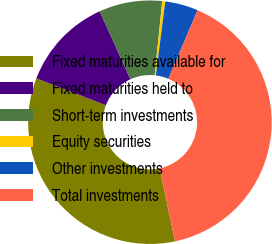Convert chart to OTSL. <chart><loc_0><loc_0><loc_500><loc_500><pie_chart><fcel>Fixed maturities available for<fcel>Fixed maturities held to<fcel>Short-term investments<fcel>Equity securities<fcel>Other investments<fcel>Total investments<nl><fcel>34.17%<fcel>12.37%<fcel>8.38%<fcel>0.4%<fcel>4.39%<fcel>40.28%<nl></chart> 